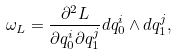<formula> <loc_0><loc_0><loc_500><loc_500>\omega _ { L } = \frac { \partial ^ { 2 } L } { \partial q _ { 0 } ^ { i } \partial q _ { 1 } ^ { j } } d q _ { 0 } ^ { i } \wedge d q _ { 1 } ^ { j } ,</formula> 